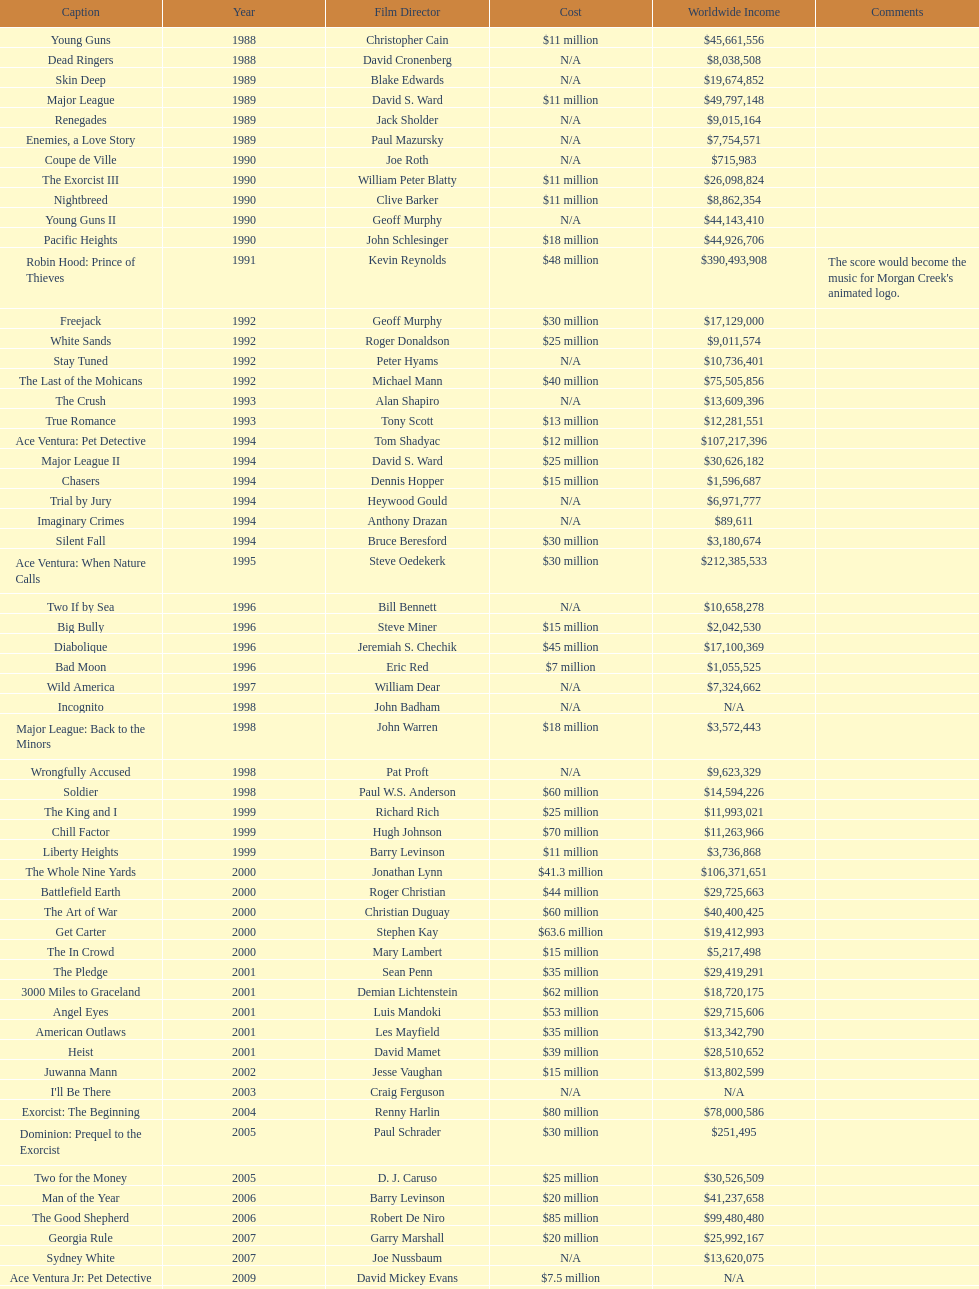Between ace ventura: when nature calls and major league: back to the minors, which movie had a larger budget? Ace Ventura: When Nature Calls. 